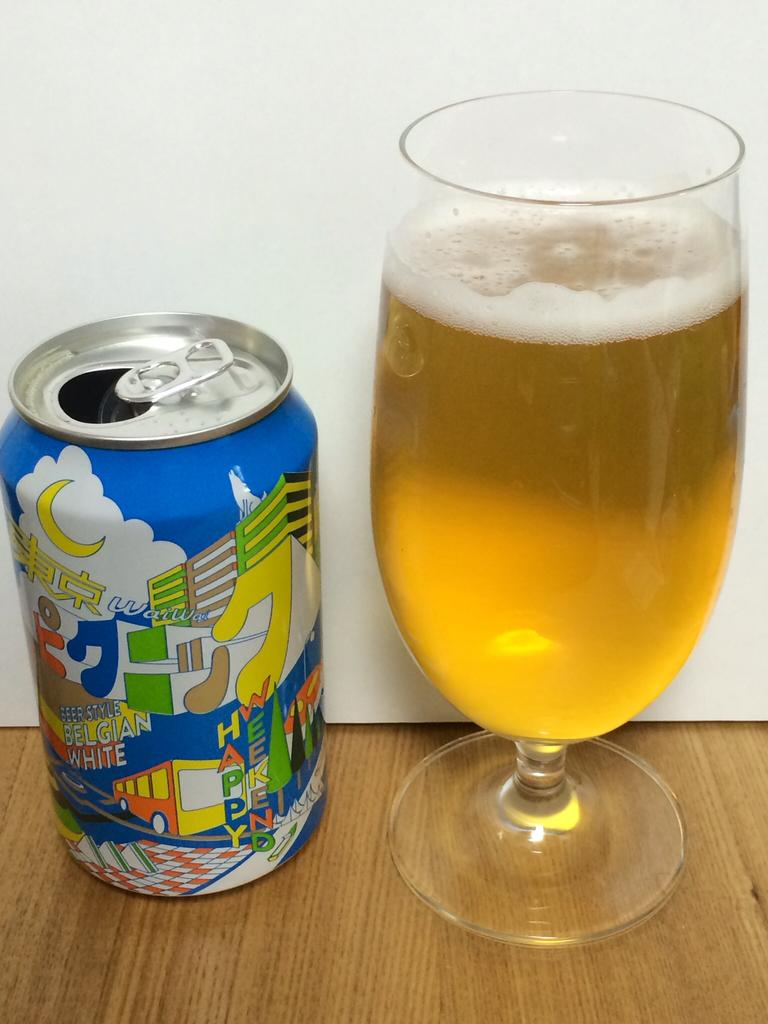<image>
Create a compact narrative representing the image presented. A can of Beer Style Belgian White is sitting next to a full glass of beer. 